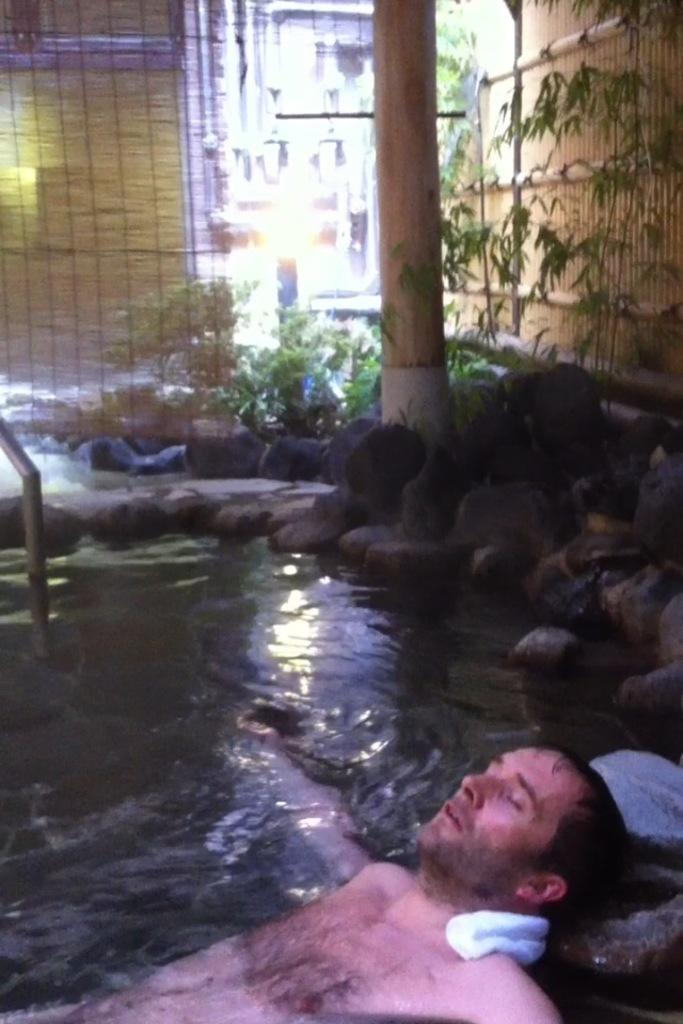What is the person in the image doing? There is a person in the water, and their head is resting on a rock. What else can be seen in the water? There are rocks in the image. What other structures are present in the image? There is a pillar in the image. What type of vegetation is visible in the image? There are plants in the image. What type of window treatment is present in the image? There are curtains in the image. What type of silk fabric is draped over the person's head in the image? There is no silk fabric present in the image; the person's head is resting on a rock. How many drops of water can be seen falling from the pillar in the image? There is no indication of water droplets falling from the pillar in the image. 